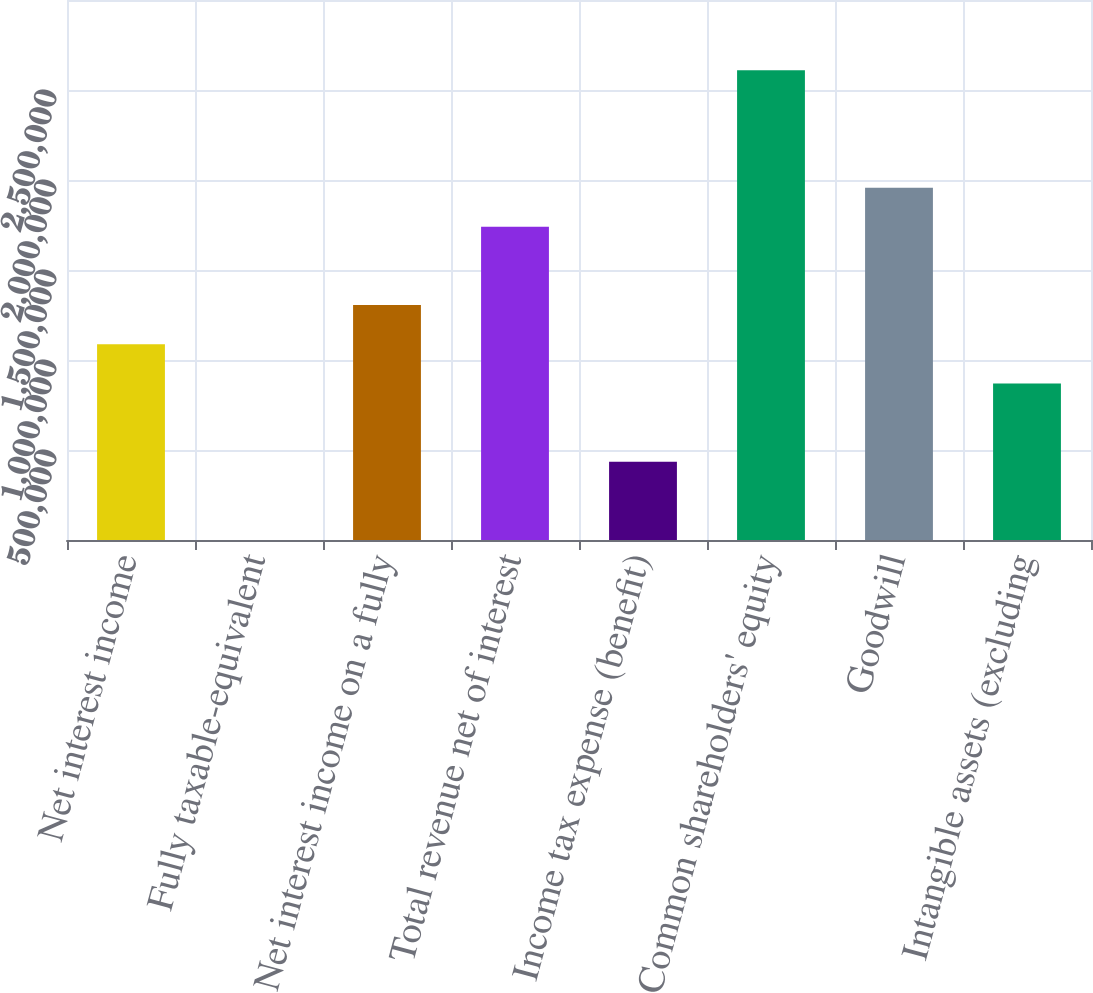Convert chart. <chart><loc_0><loc_0><loc_500><loc_500><bar_chart><fcel>Net interest income<fcel>Fully taxable-equivalent<fcel>Net interest income on a fully<fcel>Total revenue net of interest<fcel>Income tax expense (benefit)<fcel>Common shareholders' equity<fcel>Goodwill<fcel>Intangible assets (excluding<nl><fcel>1.08752e+06<fcel>211<fcel>1.30498e+06<fcel>1.7399e+06<fcel>435133<fcel>2.60974e+06<fcel>1.95736e+06<fcel>870054<nl></chart> 